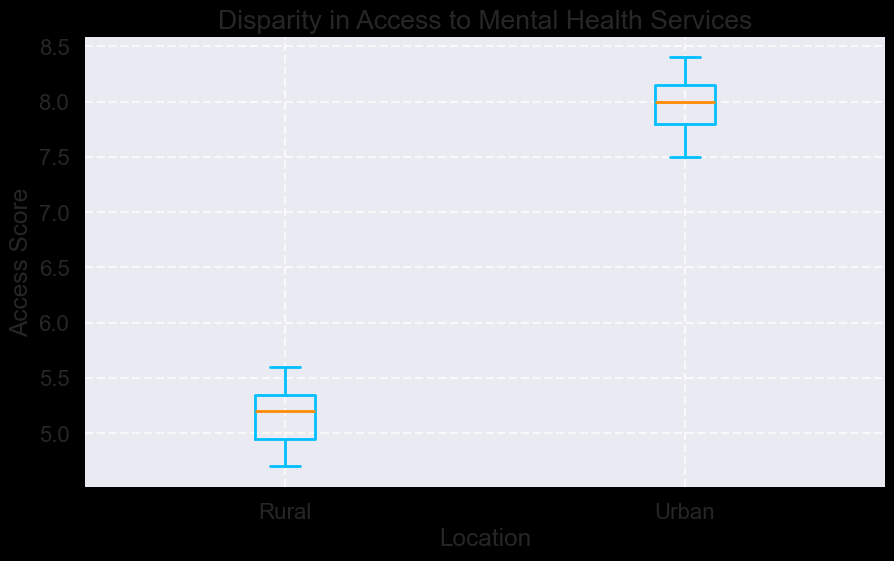What are the median access scores for urban and rural communities? To find the median access scores, look at the lines inside the boxes of the box plot. The median for urban communities is around 8.0, and for rural communities, it is approximately 5.2.
Answer: Urban: 8.0, Rural: 5.2 Which community faces more variability in access to mental health services? Variability can be assessed by looking at the interquartile range (IQR), which is the area between the bottom and top of the box. The urban community has a larger IQR, indicating more variability.
Answer: Urban What are the minimum and maximum access scores observed for rural communities? The minimum and maximum scores can be seen at the ends of the whiskers for the rural boxplot. The minimum score is around 4.7, and the maximum is around 5.6.
Answer: Min: 4.7, Max: 5.6 Compare the median access scores of urban and rural communities. By how much do they differ? Subtract the median score of the rural community from that of the urban community: 8.0 - 5.2 = 2.8.
Answer: 2.8 Is there any significant outlier observed? If so, which community does it belong to? Outliers are shown as individual points outside the whiskers. There is a significant outlier in the urban community, marked as a red dot.
Answer: Urban From which community is the access score range wider? The range is calculated by the difference between the maximum and minimum values. For urban, it ranges from about 7.5 to 8.4. For rural, it ranges from about 4.7 to 5.6. The urban community has a wider range.
Answer: Urban Which community has a higher upper quartile? The upper quartile is the top edge of the box. The upper quartile for the urban community is higher than that for the rural one, around 8.2 compared to 5.4.
Answer: Urban If the median access score were to increase by 0.5 in both communities, what would the new medians be? Add 0.5 to the existing medians. Urban: 8.0 + 0.5 = 8.5, Rural: 5.2 + 0.5 = 5.7.
Answer: Urban: 8.5, Rural: 5.7 What is the interquartile range (IQR) for the rural community? The IQR is the difference between the third quartile (Q3) and the first quartile (Q1). For the rural community, Q3 is about 5.4, and Q1 is about 5.0. So, 5.4 - 5.0 = 0.4.
Answer: 0.4 